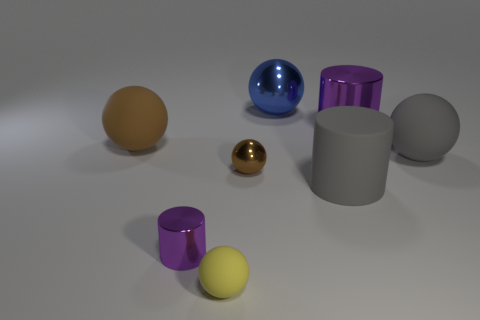What number of big brown metal cylinders are there? There are no big brown metal cylinders visible in the image. The image features various colorful spheres and cylinders, none of which are both brown and metallic. 